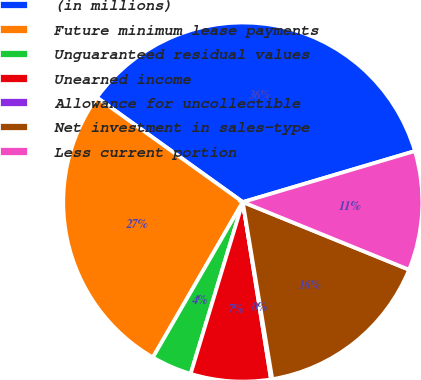Convert chart to OTSL. <chart><loc_0><loc_0><loc_500><loc_500><pie_chart><fcel>(in millions)<fcel>Future minimum lease payments<fcel>Unguaranteed residual values<fcel>Unearned income<fcel>Allowance for uncollectible<fcel>Net investment in sales-type<fcel>Less current portion<nl><fcel>35.52%<fcel>26.55%<fcel>3.66%<fcel>7.2%<fcel>0.12%<fcel>16.22%<fcel>10.74%<nl></chart> 